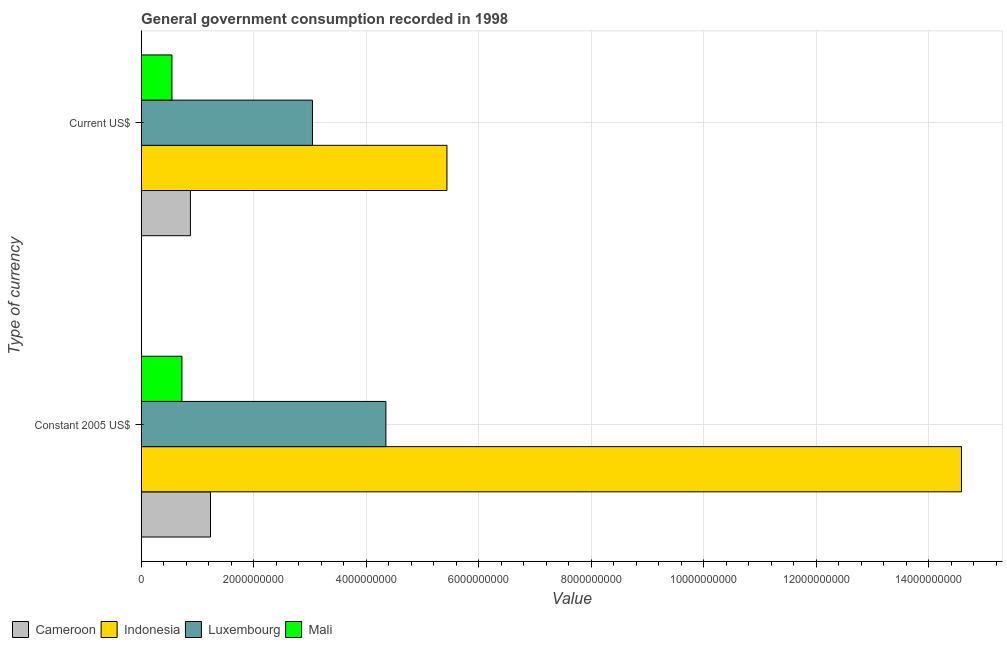How many different coloured bars are there?
Provide a short and direct response. 4. How many bars are there on the 1st tick from the top?
Provide a succinct answer. 4. How many bars are there on the 2nd tick from the bottom?
Your answer should be compact. 4. What is the label of the 1st group of bars from the top?
Provide a short and direct response. Current US$. What is the value consumed in current us$ in Indonesia?
Offer a very short reply. 5.43e+09. Across all countries, what is the maximum value consumed in current us$?
Provide a succinct answer. 5.43e+09. Across all countries, what is the minimum value consumed in current us$?
Your answer should be compact. 5.47e+08. In which country was the value consumed in current us$ maximum?
Ensure brevity in your answer.  Indonesia. In which country was the value consumed in constant 2005 us$ minimum?
Offer a terse response. Mali. What is the total value consumed in constant 2005 us$ in the graph?
Your answer should be very brief. 2.09e+1. What is the difference between the value consumed in current us$ in Indonesia and that in Luxembourg?
Your answer should be compact. 2.39e+09. What is the difference between the value consumed in current us$ in Mali and the value consumed in constant 2005 us$ in Indonesia?
Make the answer very short. -1.40e+1. What is the average value consumed in current us$ per country?
Ensure brevity in your answer.  2.48e+09. What is the difference between the value consumed in current us$ and value consumed in constant 2005 us$ in Indonesia?
Your answer should be very brief. -9.14e+09. In how many countries, is the value consumed in constant 2005 us$ greater than 3600000000 ?
Your answer should be compact. 2. What is the ratio of the value consumed in constant 2005 us$ in Mali to that in Cameroon?
Provide a short and direct response. 0.59. In how many countries, is the value consumed in constant 2005 us$ greater than the average value consumed in constant 2005 us$ taken over all countries?
Your answer should be compact. 1. What does the 2nd bar from the top in Constant 2005 US$ represents?
Your answer should be compact. Luxembourg. How many bars are there?
Offer a very short reply. 8. How many countries are there in the graph?
Offer a terse response. 4. Are the values on the major ticks of X-axis written in scientific E-notation?
Your response must be concise. No. Does the graph contain grids?
Give a very brief answer. Yes. Where does the legend appear in the graph?
Offer a very short reply. Bottom left. How many legend labels are there?
Offer a very short reply. 4. What is the title of the graph?
Provide a succinct answer. General government consumption recorded in 1998. What is the label or title of the X-axis?
Make the answer very short. Value. What is the label or title of the Y-axis?
Offer a terse response. Type of currency. What is the Value of Cameroon in Constant 2005 US$?
Offer a very short reply. 1.23e+09. What is the Value in Indonesia in Constant 2005 US$?
Ensure brevity in your answer.  1.46e+1. What is the Value in Luxembourg in Constant 2005 US$?
Ensure brevity in your answer.  4.35e+09. What is the Value of Mali in Constant 2005 US$?
Offer a very short reply. 7.25e+08. What is the Value of Cameroon in Current US$?
Keep it short and to the point. 8.76e+08. What is the Value of Indonesia in Current US$?
Keep it short and to the point. 5.43e+09. What is the Value of Luxembourg in Current US$?
Your response must be concise. 3.04e+09. What is the Value of Mali in Current US$?
Make the answer very short. 5.47e+08. Across all Type of currency, what is the maximum Value in Cameroon?
Keep it short and to the point. 1.23e+09. Across all Type of currency, what is the maximum Value in Indonesia?
Your answer should be compact. 1.46e+1. Across all Type of currency, what is the maximum Value of Luxembourg?
Offer a very short reply. 4.35e+09. Across all Type of currency, what is the maximum Value of Mali?
Your answer should be very brief. 7.25e+08. Across all Type of currency, what is the minimum Value of Cameroon?
Your response must be concise. 8.76e+08. Across all Type of currency, what is the minimum Value of Indonesia?
Make the answer very short. 5.43e+09. Across all Type of currency, what is the minimum Value in Luxembourg?
Provide a succinct answer. 3.04e+09. Across all Type of currency, what is the minimum Value in Mali?
Give a very brief answer. 5.47e+08. What is the total Value of Cameroon in the graph?
Provide a succinct answer. 2.11e+09. What is the total Value in Indonesia in the graph?
Offer a terse response. 2.00e+1. What is the total Value of Luxembourg in the graph?
Offer a terse response. 7.39e+09. What is the total Value of Mali in the graph?
Offer a very short reply. 1.27e+09. What is the difference between the Value of Cameroon in Constant 2005 US$ and that in Current US$?
Your answer should be very brief. 3.57e+08. What is the difference between the Value of Indonesia in Constant 2005 US$ and that in Current US$?
Offer a terse response. 9.14e+09. What is the difference between the Value of Luxembourg in Constant 2005 US$ and that in Current US$?
Keep it short and to the point. 1.30e+09. What is the difference between the Value in Mali in Constant 2005 US$ and that in Current US$?
Your answer should be very brief. 1.77e+08. What is the difference between the Value of Cameroon in Constant 2005 US$ and the Value of Indonesia in Current US$?
Your response must be concise. -4.20e+09. What is the difference between the Value in Cameroon in Constant 2005 US$ and the Value in Luxembourg in Current US$?
Offer a very short reply. -1.81e+09. What is the difference between the Value in Cameroon in Constant 2005 US$ and the Value in Mali in Current US$?
Offer a terse response. 6.85e+08. What is the difference between the Value of Indonesia in Constant 2005 US$ and the Value of Luxembourg in Current US$?
Make the answer very short. 1.15e+1. What is the difference between the Value in Indonesia in Constant 2005 US$ and the Value in Mali in Current US$?
Your response must be concise. 1.40e+1. What is the difference between the Value of Luxembourg in Constant 2005 US$ and the Value of Mali in Current US$?
Keep it short and to the point. 3.80e+09. What is the average Value in Cameroon per Type of currency?
Your answer should be compact. 1.05e+09. What is the average Value of Indonesia per Type of currency?
Ensure brevity in your answer.  1.00e+1. What is the average Value of Luxembourg per Type of currency?
Offer a very short reply. 3.70e+09. What is the average Value of Mali per Type of currency?
Provide a succinct answer. 6.36e+08. What is the difference between the Value in Cameroon and Value in Indonesia in Constant 2005 US$?
Keep it short and to the point. -1.33e+1. What is the difference between the Value of Cameroon and Value of Luxembourg in Constant 2005 US$?
Ensure brevity in your answer.  -3.12e+09. What is the difference between the Value in Cameroon and Value in Mali in Constant 2005 US$?
Your answer should be compact. 5.08e+08. What is the difference between the Value of Indonesia and Value of Luxembourg in Constant 2005 US$?
Your answer should be compact. 1.02e+1. What is the difference between the Value of Indonesia and Value of Mali in Constant 2005 US$?
Your answer should be very brief. 1.39e+1. What is the difference between the Value in Luxembourg and Value in Mali in Constant 2005 US$?
Offer a very short reply. 3.62e+09. What is the difference between the Value in Cameroon and Value in Indonesia in Current US$?
Offer a terse response. -4.56e+09. What is the difference between the Value of Cameroon and Value of Luxembourg in Current US$?
Your answer should be compact. -2.17e+09. What is the difference between the Value in Cameroon and Value in Mali in Current US$?
Keep it short and to the point. 3.28e+08. What is the difference between the Value of Indonesia and Value of Luxembourg in Current US$?
Provide a succinct answer. 2.39e+09. What is the difference between the Value in Indonesia and Value in Mali in Current US$?
Your answer should be very brief. 4.89e+09. What is the difference between the Value in Luxembourg and Value in Mali in Current US$?
Provide a short and direct response. 2.50e+09. What is the ratio of the Value in Cameroon in Constant 2005 US$ to that in Current US$?
Your response must be concise. 1.41. What is the ratio of the Value in Indonesia in Constant 2005 US$ to that in Current US$?
Provide a succinct answer. 2.68. What is the ratio of the Value of Luxembourg in Constant 2005 US$ to that in Current US$?
Offer a very short reply. 1.43. What is the ratio of the Value in Mali in Constant 2005 US$ to that in Current US$?
Your answer should be compact. 1.32. What is the difference between the highest and the second highest Value of Cameroon?
Your answer should be compact. 3.57e+08. What is the difference between the highest and the second highest Value in Indonesia?
Your answer should be compact. 9.14e+09. What is the difference between the highest and the second highest Value in Luxembourg?
Your answer should be compact. 1.30e+09. What is the difference between the highest and the second highest Value in Mali?
Your answer should be very brief. 1.77e+08. What is the difference between the highest and the lowest Value in Cameroon?
Make the answer very short. 3.57e+08. What is the difference between the highest and the lowest Value of Indonesia?
Your answer should be very brief. 9.14e+09. What is the difference between the highest and the lowest Value of Luxembourg?
Provide a succinct answer. 1.30e+09. What is the difference between the highest and the lowest Value of Mali?
Make the answer very short. 1.77e+08. 